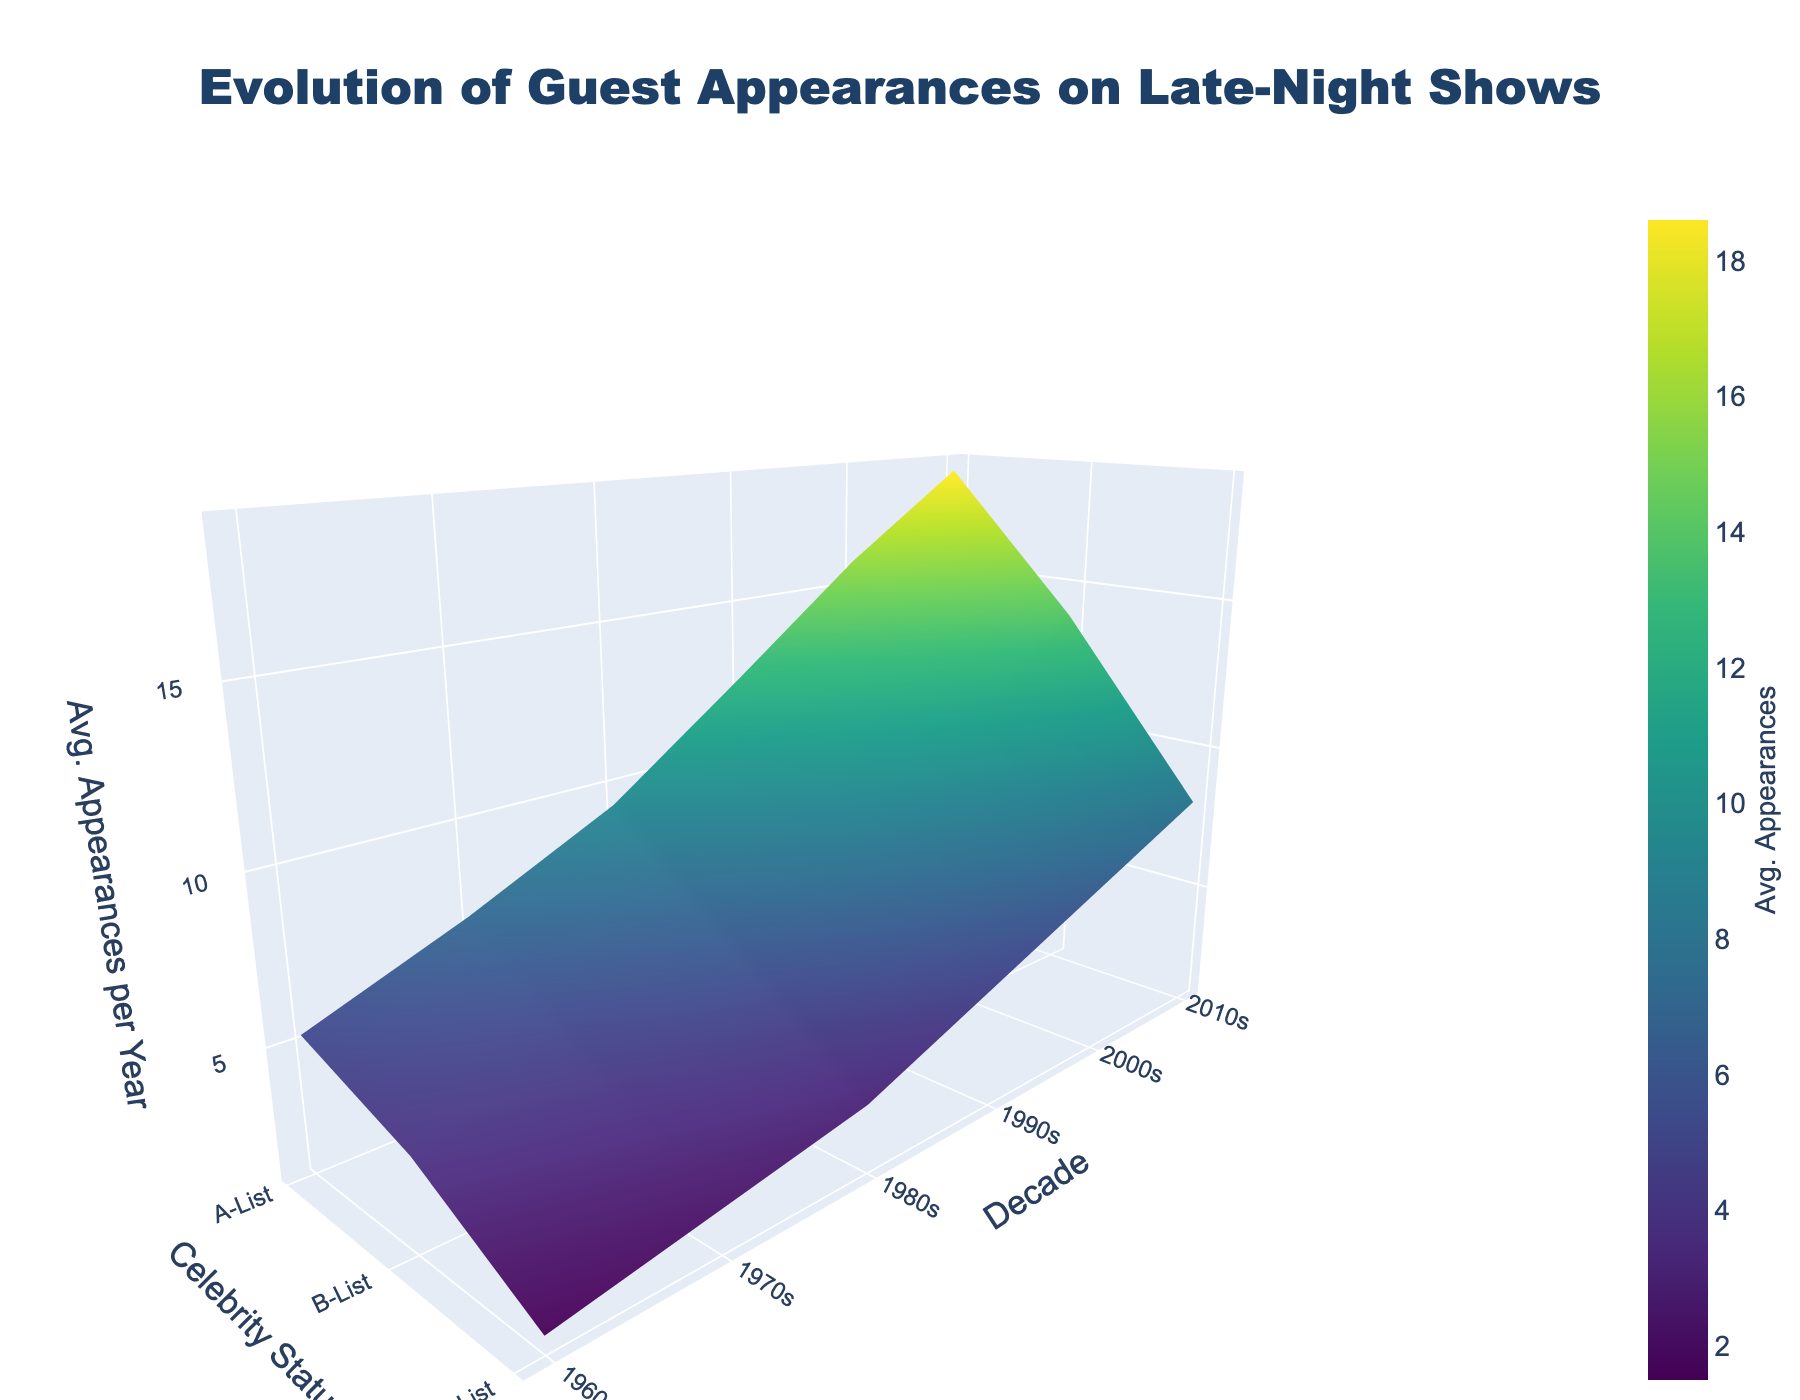How does guest appearance frequency change over the decades for A-List celebrities? Look at the 3D surface plot and focus on the A-List celebrity status across the decades from the 1960s to the 2010s. Note that the average guest appearances start at 5.2 in the 1960s and increase to 18.6 in the 2010s.
Answer: It increases Which decade shows the sharpest increase in average guest appearances for B-List celebrities? Compare the average guest appearances for B-List celebrities between consecutive decades. The difference between the 2000s (11.2) and 2010s (13.9) is 2.7, which is the highest difference observed among decade changes for B-List celebrities.
Answer: 2010s What is the shape of the variation in guest appearances over the decades? Examine the surface plot's overall shape by observing how the z-axis values (average guest appearances) vary with the x-axis (celebrity status) and y-axis (decades). From the 1960s to the 2010s, the surface generally rises, indicating an increase in guest appearances over time for all celebrity statuses.
Answer: Increasing trend What decade and celebrity status combination has the lowest average guest appearances? Identify the lowest peak on the 3D surface plot. By checking the minimum z-value (1.5) and tracing it back to its corresponding decade and celebrity status, it is found in the 1960s for C-List celebrities.
Answer: 1960s, C-List celebrities By how many appearances did C-List guest appearances increase from the 1960s to the 2010s? Compare the average guest appearances for C-List celebrities between the 1960s (1.5) and the 2010s (8.2). Calculate the difference: 8.2 - 1.5 = 6.7.
Answer: 6.7 Which celebrity status showed the highest average guest appearances in the 1990s? Look at the surface plot's layer representing the 1990s and compare the values for A-List, B-List, and C-List celebrities. A-List has the highest value at 12.5.
Answer: A-List What is the overall trend in guest appearances for C-List celebrities over the decades? Identify the values for C-List celebrities across the decades: 1960s (1.5), 1970s (2.3), 1980s (3.1), 1990s (4.8), 2000s (6.5), 2010s (8.2). Notice the values increase consistently.
Answer: Increasing trend Is the increase in average guest appearances from the 2000s to the 2010s more significant for A-List or B-List celebrities? Calculate the difference between the 2000s and 2010s for both A-List (18.6 - 15.8 = 2.8) and B-List (13.9 - 11.2 = 2.7). Compare these differences.
Answer: A-List Which decade shows the smallest increase in guest appearances for A-List celebrities compared to the previous decade? Calculate the differences between each consecutive decade's values for A-List celebrities and compare them: 1970s-1960s (7.1 - 5.2 = 1.9), 1980s-1970s (9.3 - 7.1 = 2.2), 1990s-1980s (12.5 - 9.3 = 3.2), 2000s-1990s (15.8 - 12.5 = 3.3), 2010s-2000s (18.6 - 15.8 = 2.8). The smallest increase is between the 1960s and 1970s at 1.9.
Answer: 1970s 